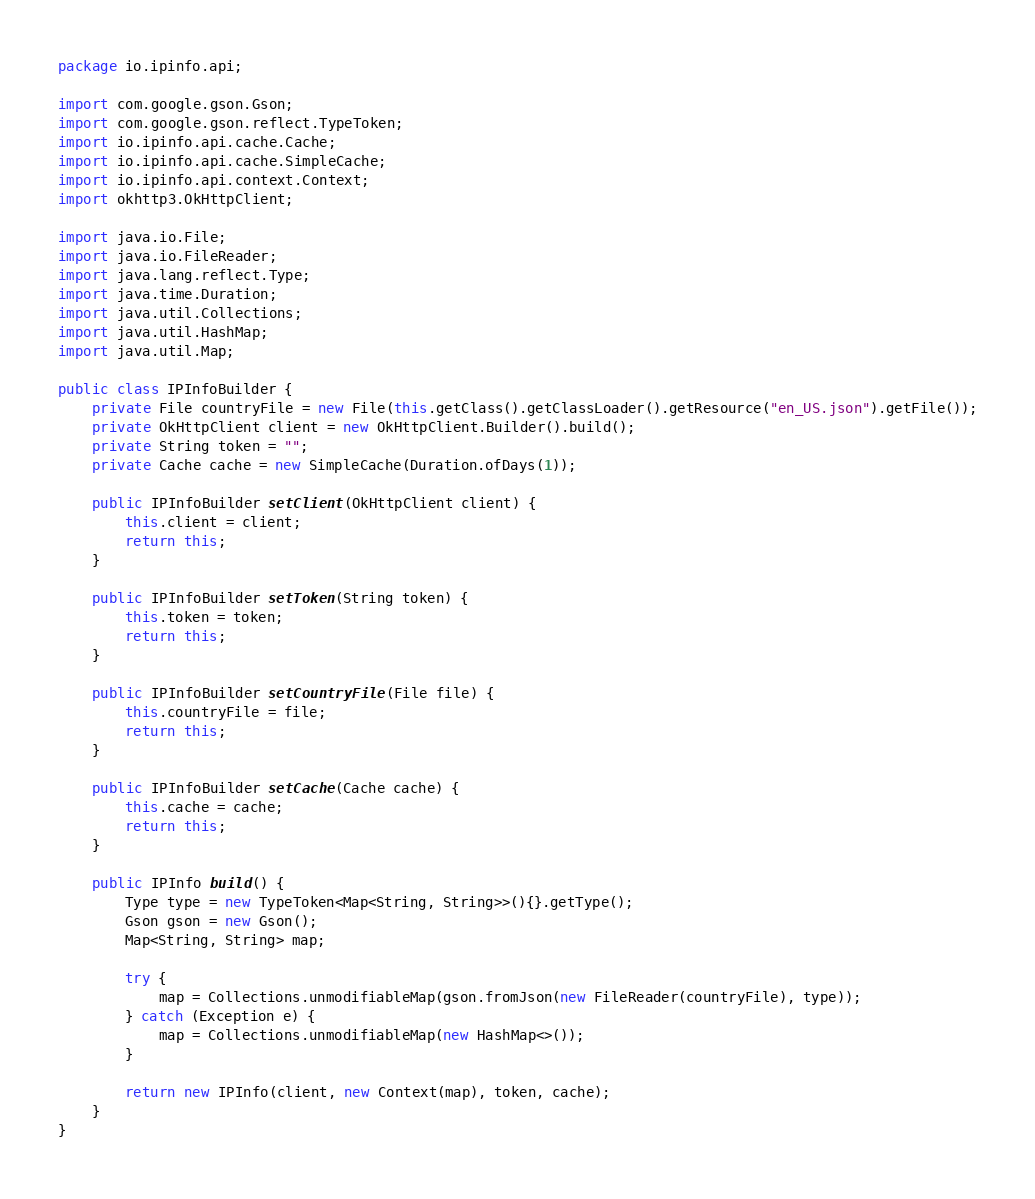Convert code to text. <code><loc_0><loc_0><loc_500><loc_500><_Java_>package io.ipinfo.api;

import com.google.gson.Gson;
import com.google.gson.reflect.TypeToken;
import io.ipinfo.api.cache.Cache;
import io.ipinfo.api.cache.SimpleCache;
import io.ipinfo.api.context.Context;
import okhttp3.OkHttpClient;

import java.io.File;
import java.io.FileReader;
import java.lang.reflect.Type;
import java.time.Duration;
import java.util.Collections;
import java.util.HashMap;
import java.util.Map;

public class IPInfoBuilder {
    private File countryFile = new File(this.getClass().getClassLoader().getResource("en_US.json").getFile());
    private OkHttpClient client = new OkHttpClient.Builder().build();
    private String token = "";
    private Cache cache = new SimpleCache(Duration.ofDays(1));

    public IPInfoBuilder setClient(OkHttpClient client) {
        this.client = client;
        return this;
    }

    public IPInfoBuilder setToken(String token) {
        this.token = token;
        return this;
    }

    public IPInfoBuilder setCountryFile(File file) {
        this.countryFile = file;
        return this;
    }

    public IPInfoBuilder setCache(Cache cache) {
        this.cache = cache;
        return this;
    }

    public IPInfo build() {
        Type type = new TypeToken<Map<String, String>>(){}.getType();
        Gson gson = new Gson();
        Map<String, String> map;

        try {
            map = Collections.unmodifiableMap(gson.fromJson(new FileReader(countryFile), type));
        } catch (Exception e) {
            map = Collections.unmodifiableMap(new HashMap<>());
        }

        return new IPInfo(client, new Context(map), token, cache);
    }
}</code> 